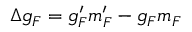Convert formula to latex. <formula><loc_0><loc_0><loc_500><loc_500>\Delta g _ { F } = g _ { F } ^ { \prime } m _ { F } ^ { \prime } - g _ { F } m _ { F }</formula> 